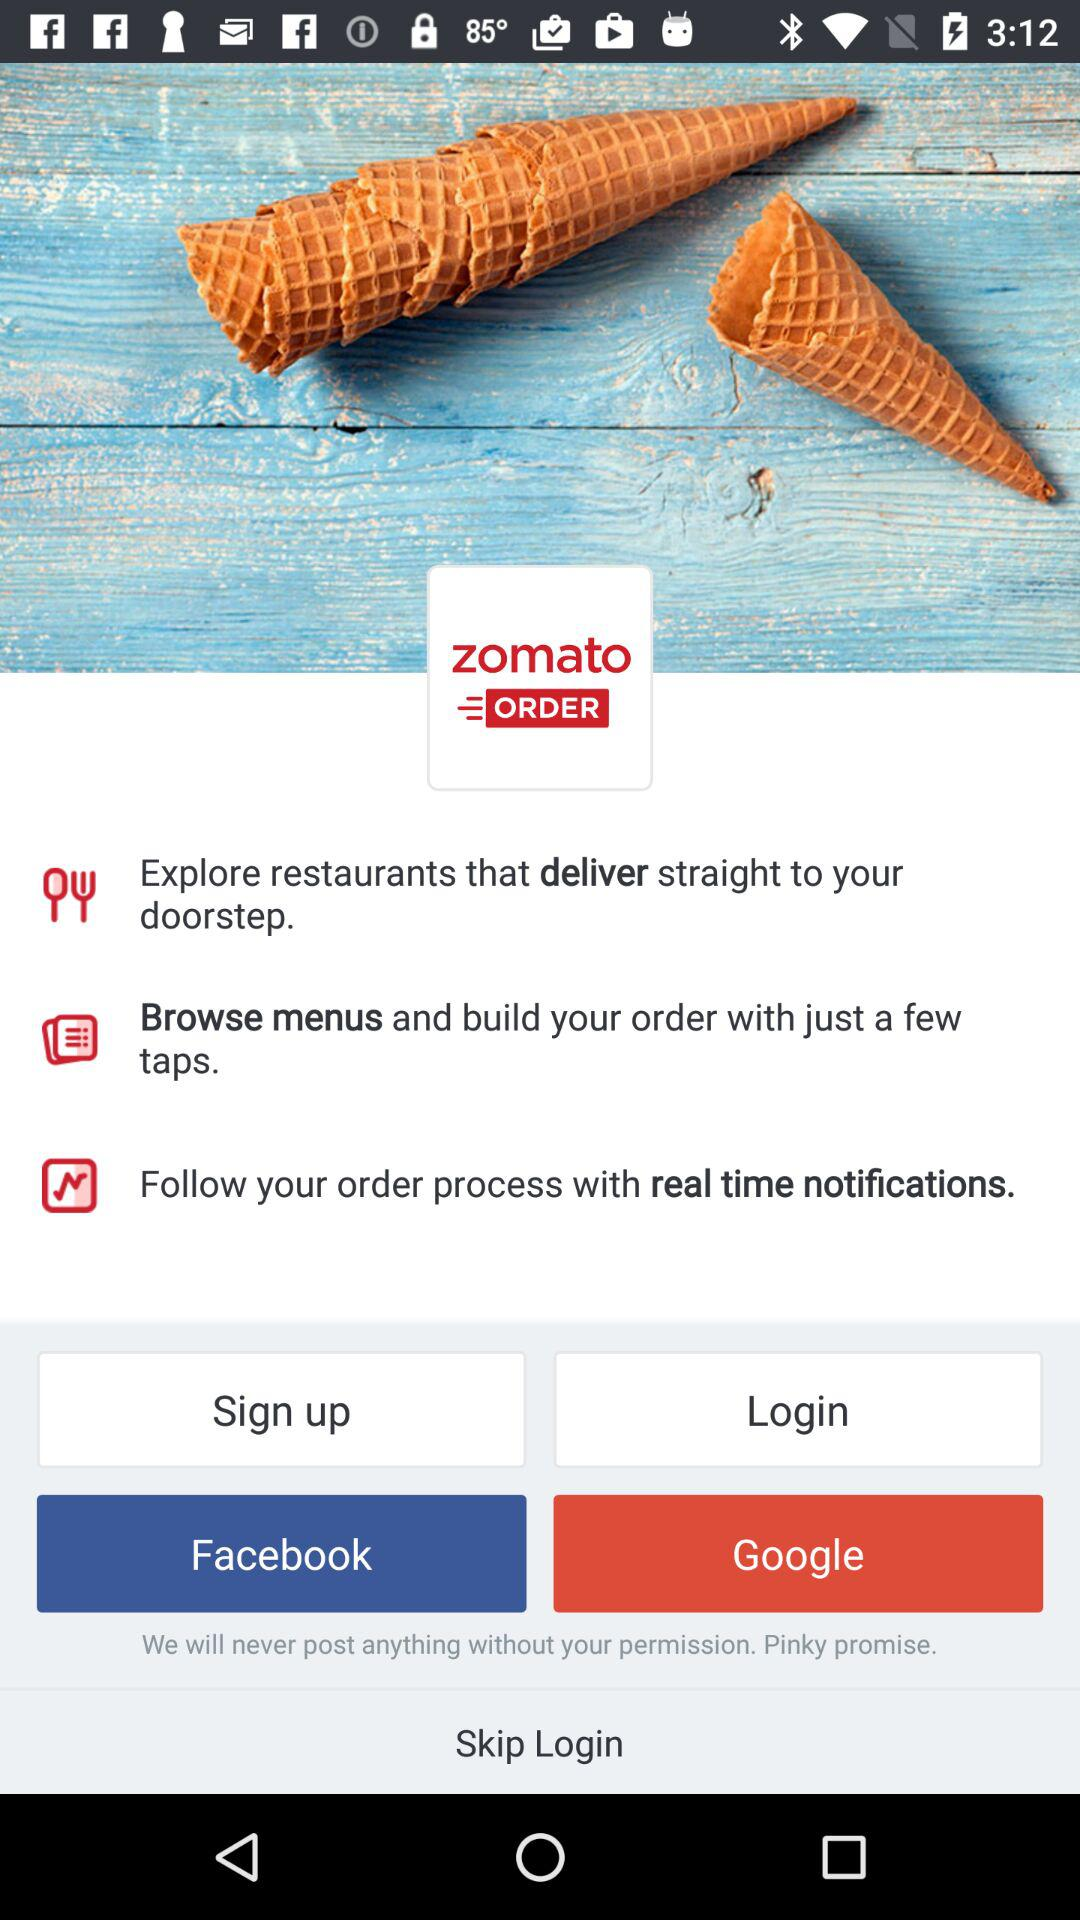What is the option to log in? The options to log in are "Facebook" and "Google". 